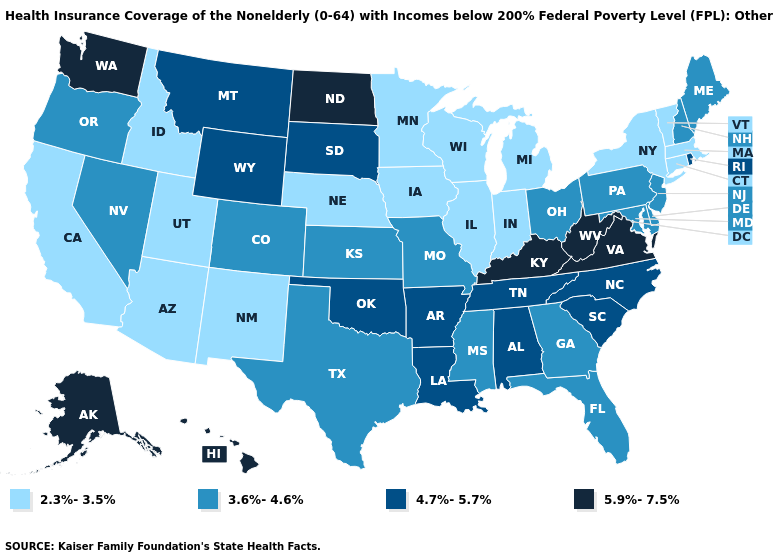What is the lowest value in states that border Washington?
Short answer required. 2.3%-3.5%. Among the states that border Colorado , does Nebraska have the highest value?
Concise answer only. No. Does Nevada have a higher value than Michigan?
Keep it brief. Yes. What is the value of Michigan?
Give a very brief answer. 2.3%-3.5%. What is the value of Georgia?
Be succinct. 3.6%-4.6%. Does New Mexico have the lowest value in the West?
Keep it brief. Yes. Which states have the lowest value in the USA?
Short answer required. Arizona, California, Connecticut, Idaho, Illinois, Indiana, Iowa, Massachusetts, Michigan, Minnesota, Nebraska, New Mexico, New York, Utah, Vermont, Wisconsin. Which states have the lowest value in the USA?
Keep it brief. Arizona, California, Connecticut, Idaho, Illinois, Indiana, Iowa, Massachusetts, Michigan, Minnesota, Nebraska, New Mexico, New York, Utah, Vermont, Wisconsin. Does the map have missing data?
Concise answer only. No. How many symbols are there in the legend?
Quick response, please. 4. What is the value of Montana?
Short answer required. 4.7%-5.7%. Name the states that have a value in the range 2.3%-3.5%?
Quick response, please. Arizona, California, Connecticut, Idaho, Illinois, Indiana, Iowa, Massachusetts, Michigan, Minnesota, Nebraska, New Mexico, New York, Utah, Vermont, Wisconsin. Name the states that have a value in the range 3.6%-4.6%?
Write a very short answer. Colorado, Delaware, Florida, Georgia, Kansas, Maine, Maryland, Mississippi, Missouri, Nevada, New Hampshire, New Jersey, Ohio, Oregon, Pennsylvania, Texas. Name the states that have a value in the range 5.9%-7.5%?
Quick response, please. Alaska, Hawaii, Kentucky, North Dakota, Virginia, Washington, West Virginia. Which states have the lowest value in the MidWest?
Keep it brief. Illinois, Indiana, Iowa, Michigan, Minnesota, Nebraska, Wisconsin. 